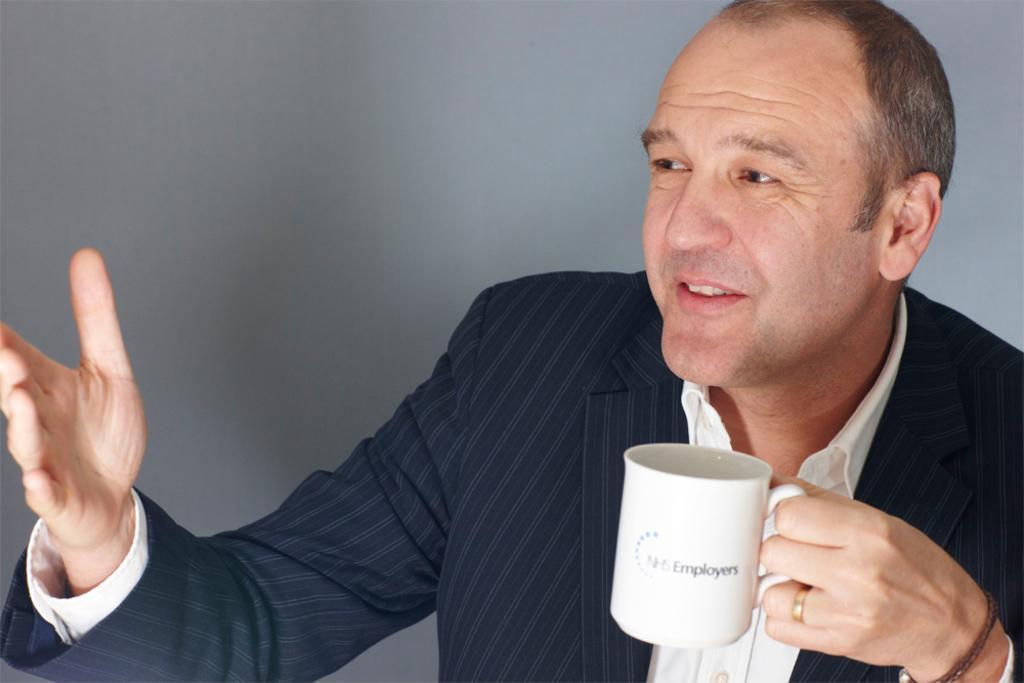Can you describe this image briefly? In this image I can see a person smiling and holding the cup. 